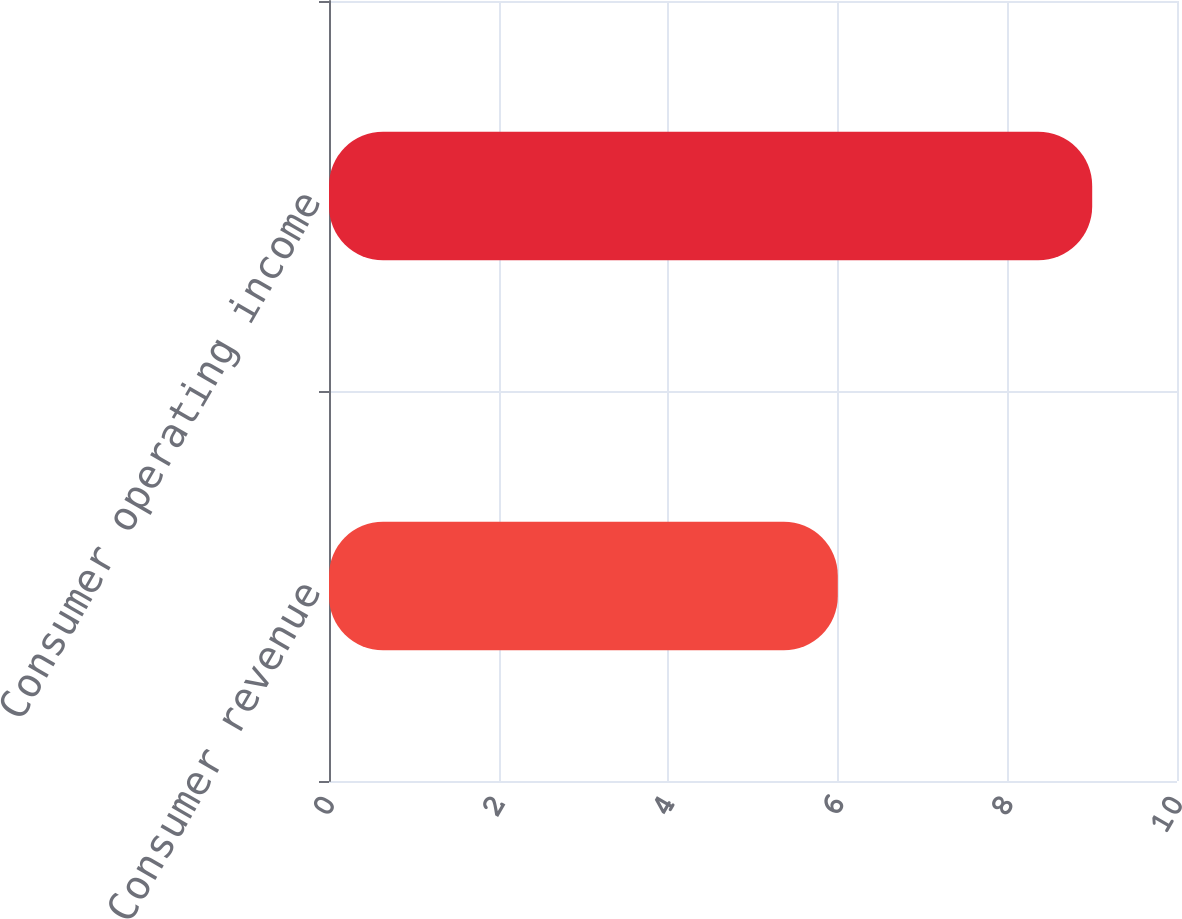<chart> <loc_0><loc_0><loc_500><loc_500><bar_chart><fcel>Consumer revenue<fcel>Consumer operating income<nl><fcel>6<fcel>9<nl></chart> 